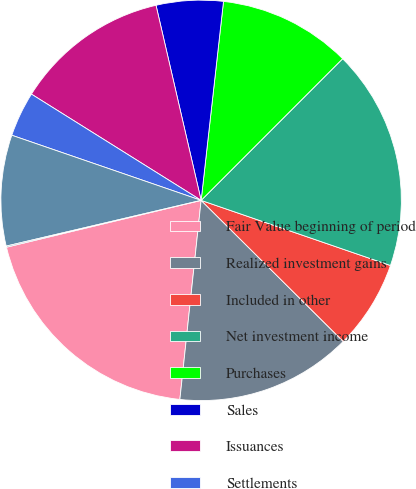Convert chart. <chart><loc_0><loc_0><loc_500><loc_500><pie_chart><fcel>Fair Value beginning of period<fcel>Realized investment gains<fcel>Included in other<fcel>Net investment income<fcel>Purchases<fcel>Sales<fcel>Issuances<fcel>Settlements<fcel>Foreign currency translation<fcel>Other(1)<nl><fcel>19.55%<fcel>14.25%<fcel>7.17%<fcel>17.78%<fcel>10.71%<fcel>5.4%<fcel>12.48%<fcel>3.63%<fcel>8.94%<fcel>0.09%<nl></chart> 